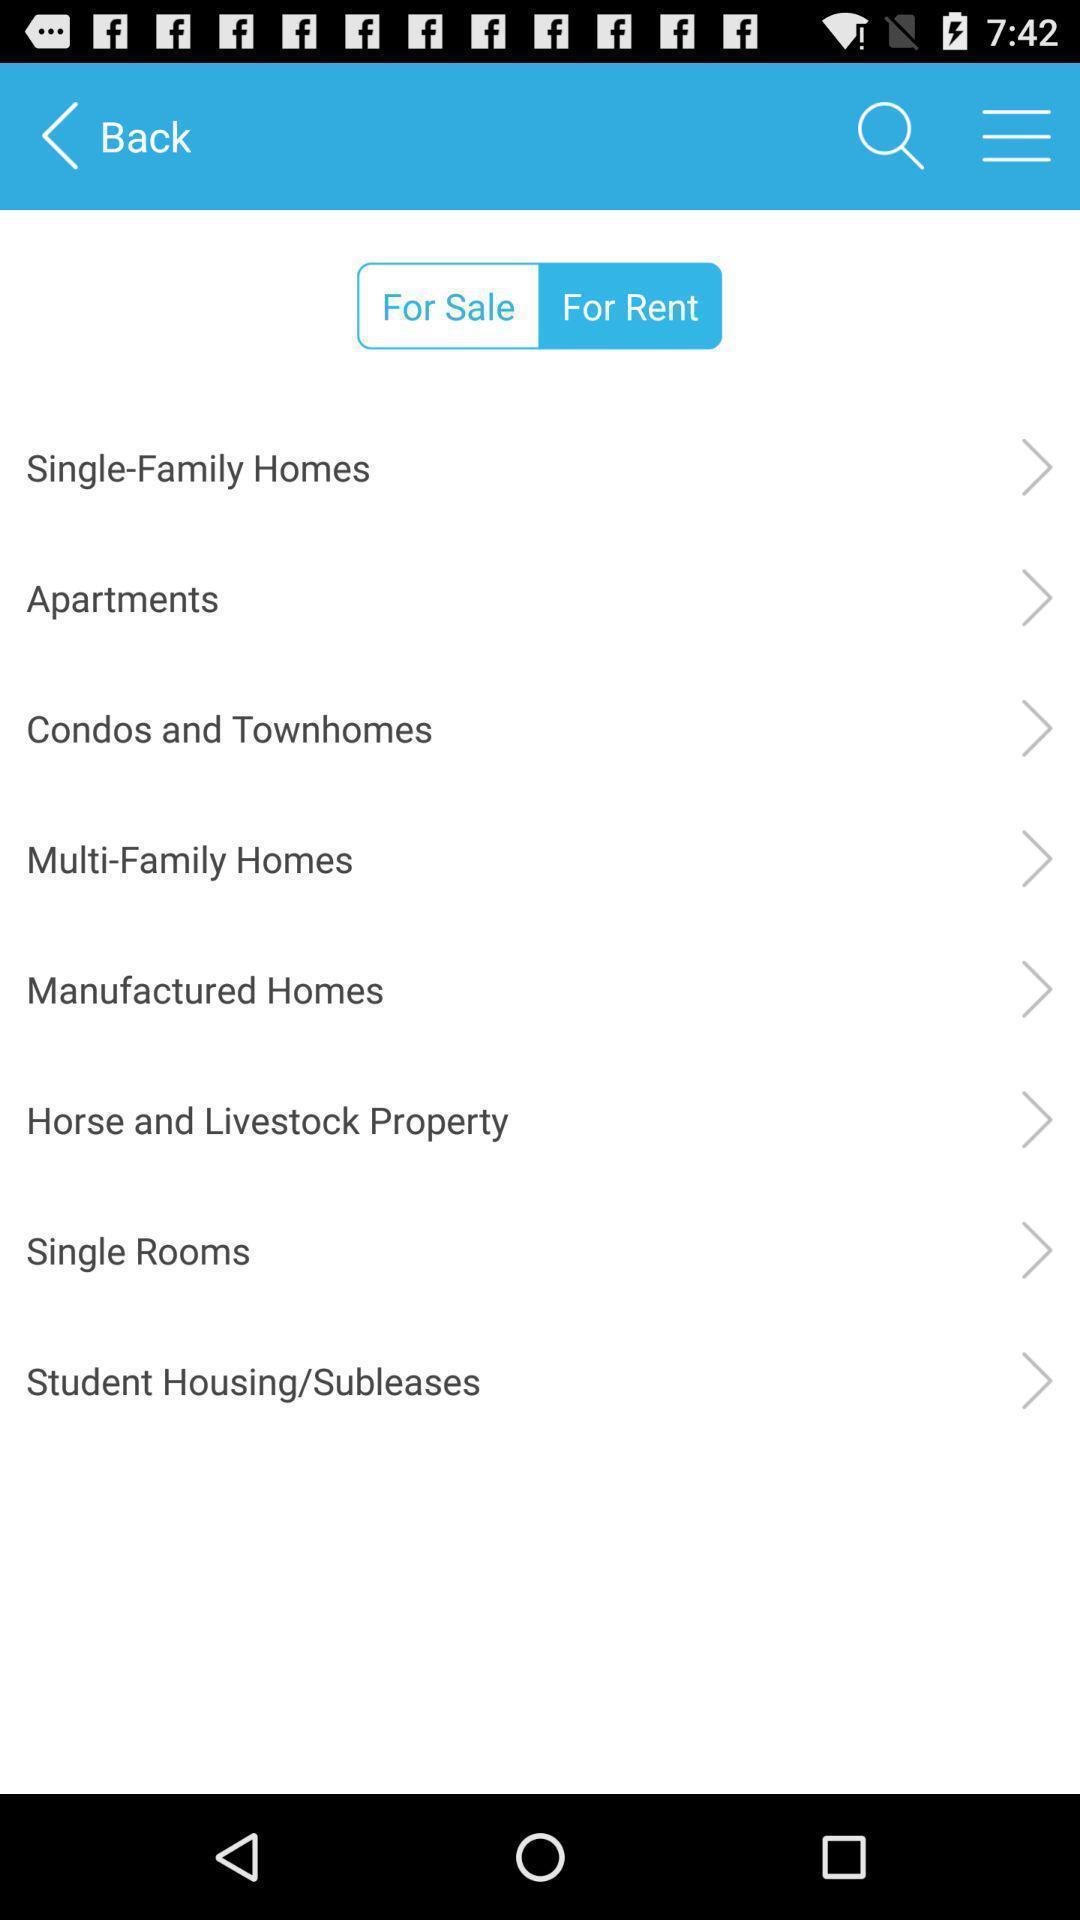Describe this image in words. Page showing different options in a house rent app. 